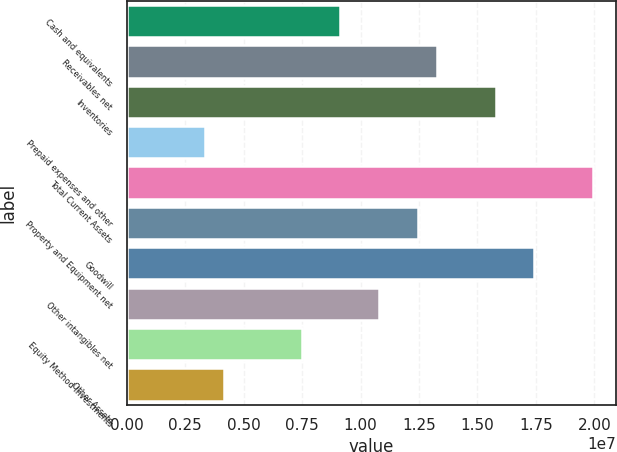<chart> <loc_0><loc_0><loc_500><loc_500><bar_chart><fcel>Cash and equivalents<fcel>Receivables net<fcel>Inventories<fcel>Prepaid expenses and other<fcel>Total Current Assets<fcel>Property and Equipment net<fcel>Goodwill<fcel>Other intangibles net<fcel>Equity Method Investments<fcel>Other Assets<nl><fcel>9.13321e+06<fcel>1.32833e+07<fcel>1.57733e+07<fcel>3.32312e+06<fcel>1.99234e+07<fcel>1.24533e+07<fcel>1.74333e+07<fcel>1.07932e+07<fcel>7.47319e+06<fcel>4.15314e+06<nl></chart> 